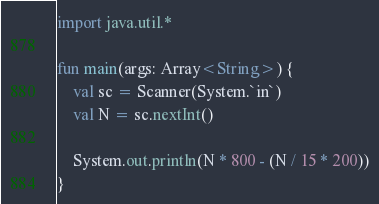Convert code to text. <code><loc_0><loc_0><loc_500><loc_500><_Kotlin_>import java.util.*

fun main(args: Array<String>) {
    val sc = Scanner(System.`in`)
    val N = sc.nextInt()

    System.out.println(N * 800 - (N / 15 * 200))
}
</code> 